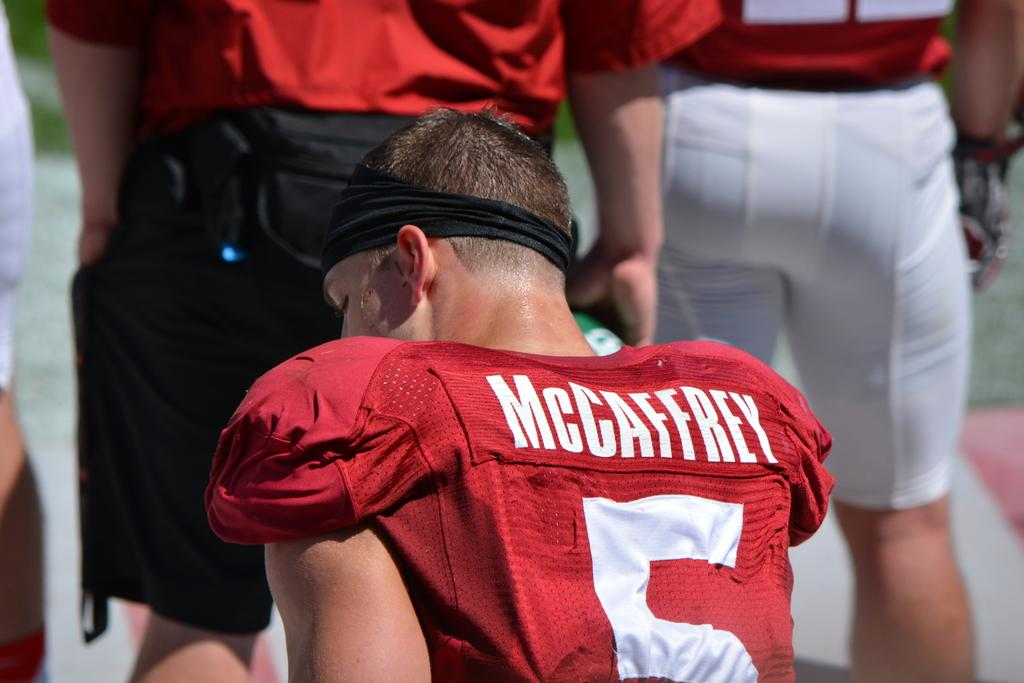<image>
Share a concise interpretation of the image provided. McCaffrey is player number 5 on this team with red uniforms. 